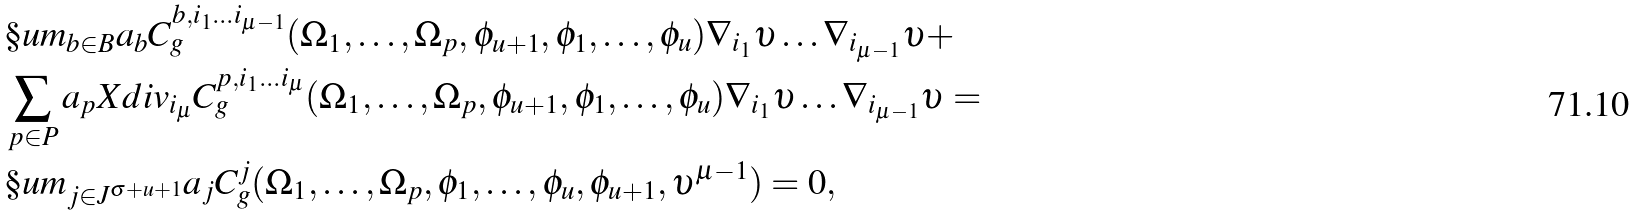<formula> <loc_0><loc_0><loc_500><loc_500>& \S u m _ { b \in B } a _ { b } C ^ { b , i _ { 1 } \dots i _ { \mu - 1 } } _ { g } ( \Omega _ { 1 } , \dots , \Omega _ { p } , \phi _ { u + 1 } , \phi _ { 1 } , \dots , \phi _ { u } ) \nabla _ { i _ { 1 } } \upsilon \dots \nabla _ { i _ { \mu - 1 } } \upsilon + \\ & \sum _ { p \in P } a _ { p } X d i v _ { i _ { \mu } } C ^ { p , i _ { 1 } \dots i _ { \mu } } _ { g } ( \Omega _ { 1 } , \dots , \Omega _ { p } , \phi _ { u + 1 } , \phi _ { 1 } , \dots , \phi _ { u } ) \nabla _ { i _ { 1 } } \upsilon \dots \nabla _ { i _ { \mu - 1 } } \upsilon = \\ & \S u m _ { j \in J ^ { \sigma + u + 1 } } a _ { j } C ^ { j } _ { g } ( \Omega _ { 1 } , \dots , \Omega _ { p } , \phi _ { 1 } , \dots , \phi _ { u } , \phi _ { u + 1 } , \upsilon ^ { \mu - 1 } ) = 0 ,</formula> 